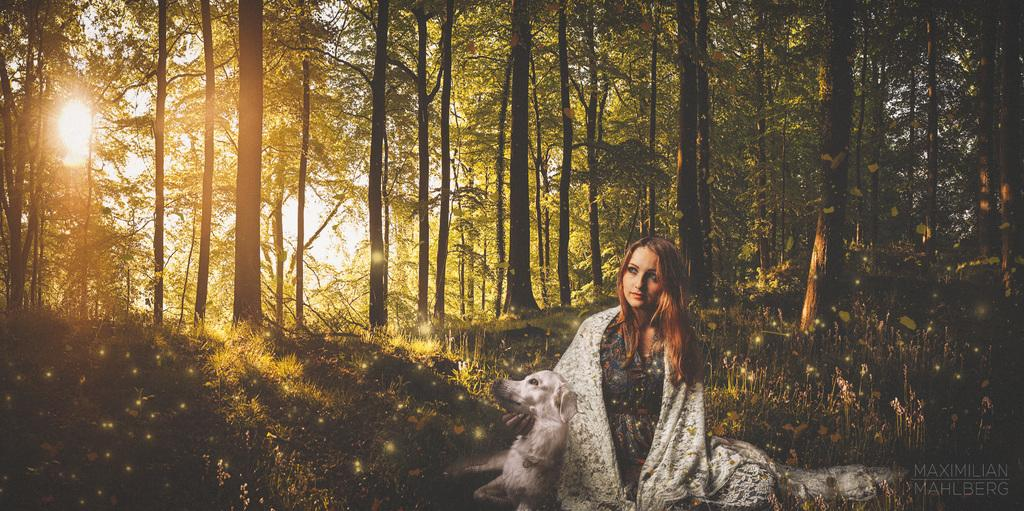Who is present in the image? There is a woman and a dog in the image. What are the woman and the dog doing in the image? Both the woman and the dog are sitting on the grass. What can be seen in the background of the image? There are trees with branches and leaves in the image. What is the lighting condition in the image? There is sunlight in the image. What type of vegetation is present in the image? Small plants are present in the image. Can you tell if the image has been altered or edited? The image may have been edited. What color is the paint used to create the rain in the image? There is no rain present in the image. 